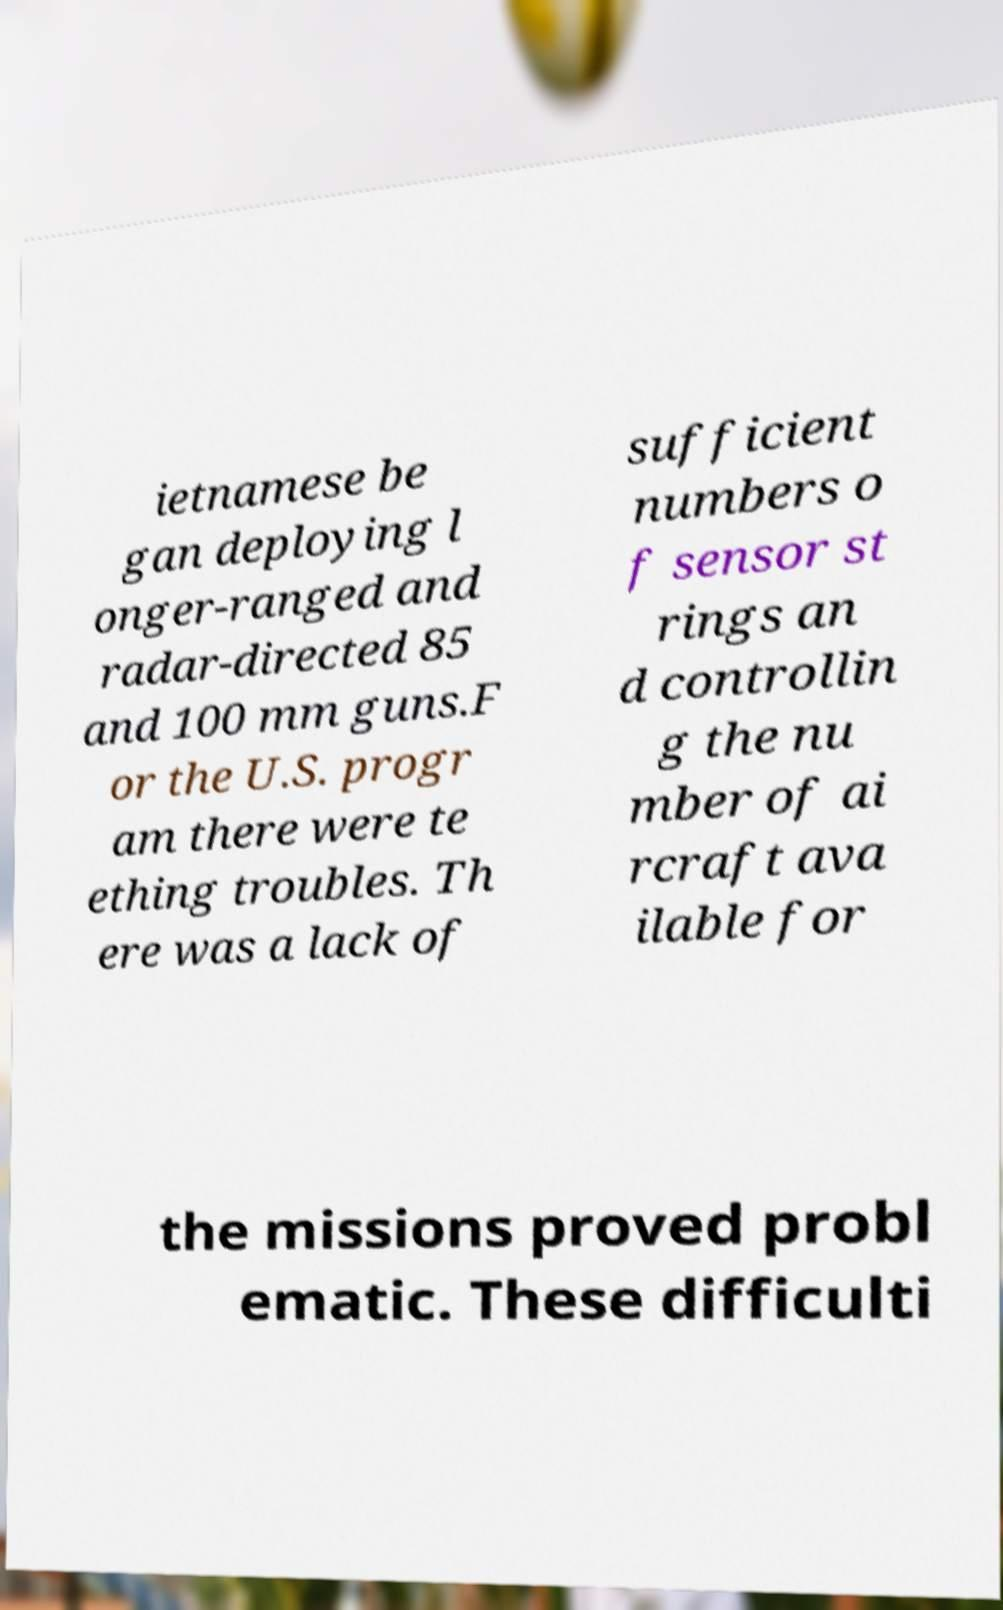Can you accurately transcribe the text from the provided image for me? ietnamese be gan deploying l onger-ranged and radar-directed 85 and 100 mm guns.F or the U.S. progr am there were te ething troubles. Th ere was a lack of sufficient numbers o f sensor st rings an d controllin g the nu mber of ai rcraft ava ilable for the missions proved probl ematic. These difficulti 